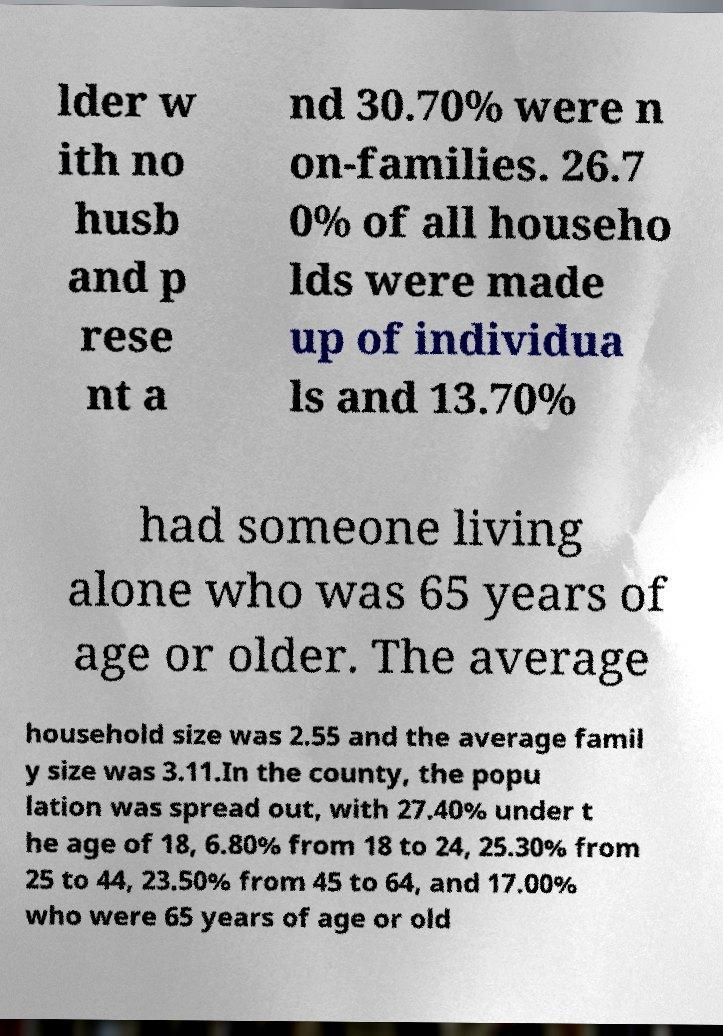Could you assist in decoding the text presented in this image and type it out clearly? lder w ith no husb and p rese nt a nd 30.70% were n on-families. 26.7 0% of all househo lds were made up of individua ls and 13.70% had someone living alone who was 65 years of age or older. The average household size was 2.55 and the average famil y size was 3.11.In the county, the popu lation was spread out, with 27.40% under t he age of 18, 6.80% from 18 to 24, 25.30% from 25 to 44, 23.50% from 45 to 64, and 17.00% who were 65 years of age or old 